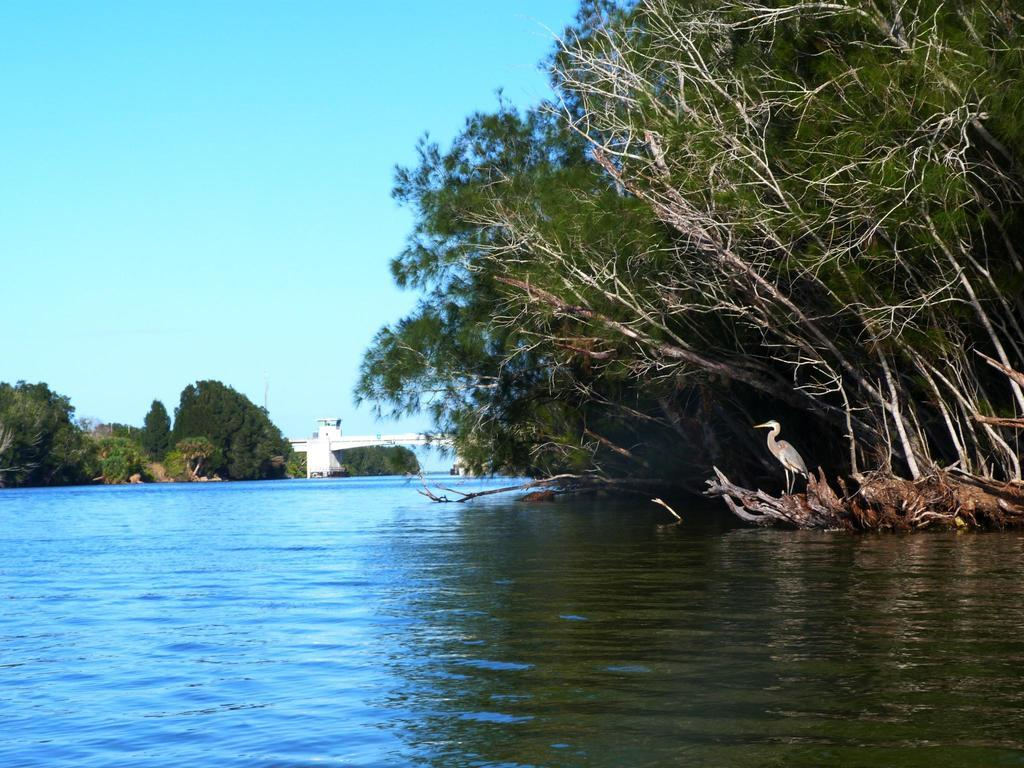What is the primary element present in the image? There is water in the image. Can you describe the structure near the tree? There is a crane at the root of a tree in the image. What can be seen at the center of the image? There is a bridge at the center of the image. What type of vegetation is visible in the background? There are trees in the background of the image. What part of the natural environment is visible in the image? The sky is visible in the background of the image. What type of news is being reported by the bird in the image? There is no bird or news reporting present in the image. How many people are being lifted by the crane in the image? There are no people being lifted by the crane in the image; it is near a tree. 